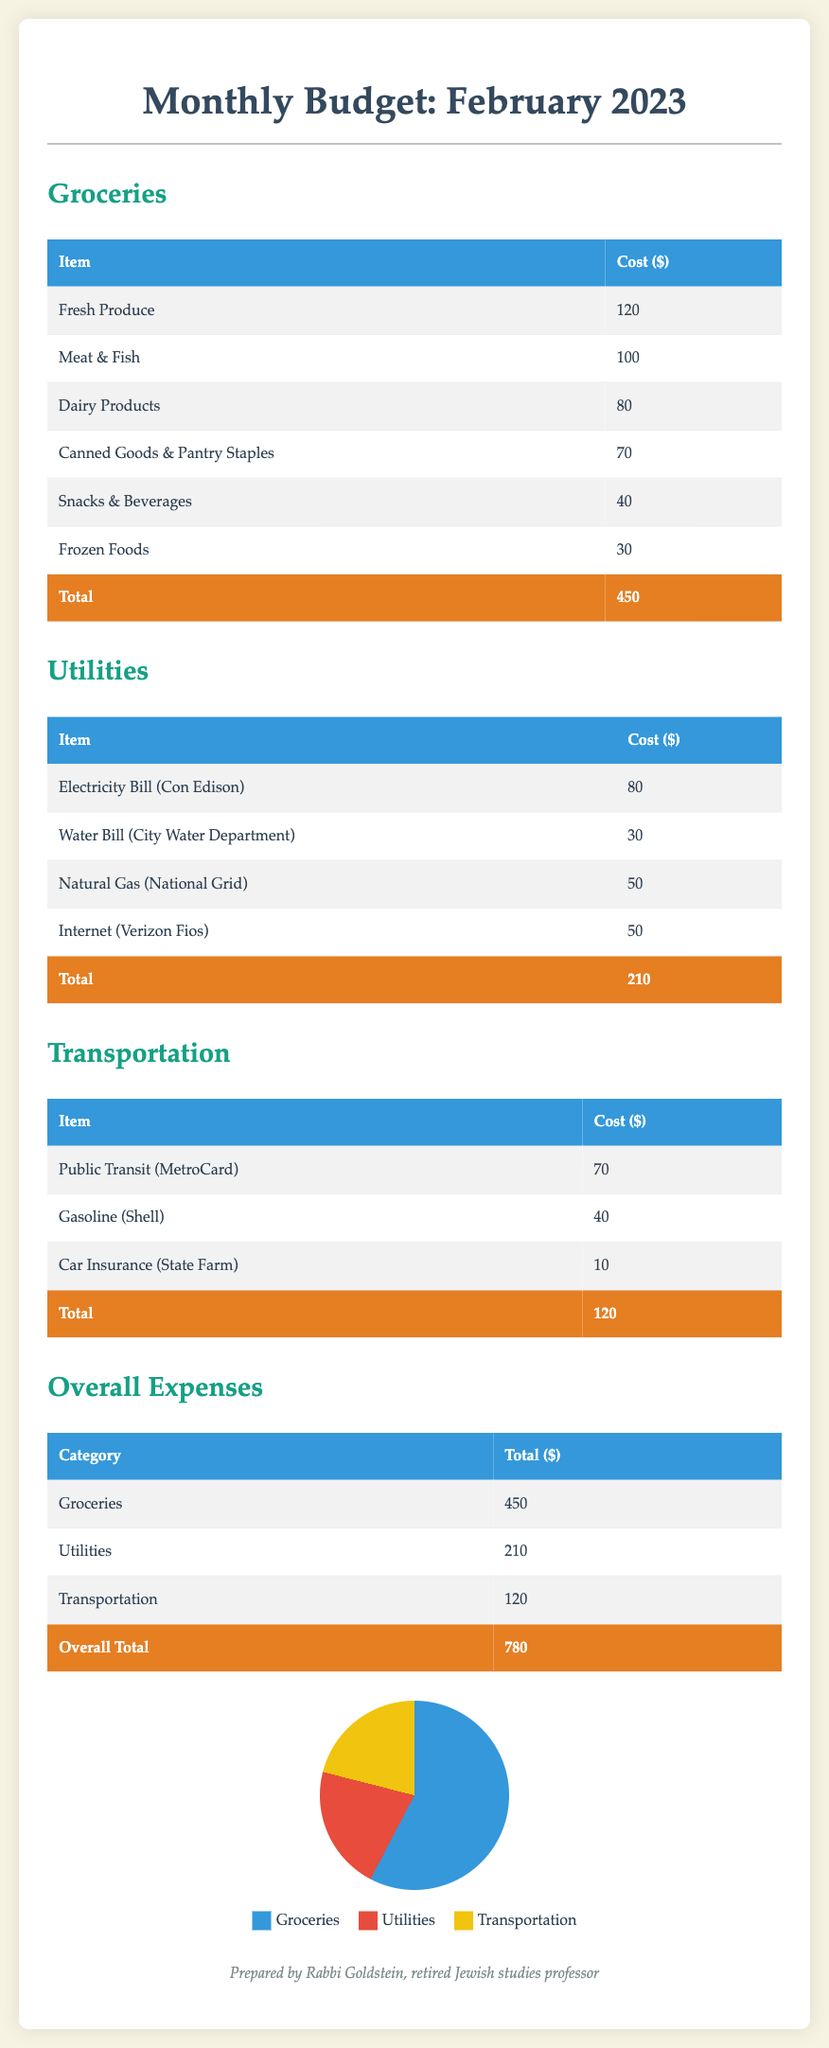What is the total cost for groceries? The total cost for groceries is calculated by adding all grocery items, which is $120 + $100 + $80 + $70 + $40 + $30 = $450.
Answer: $450 What is the cost of the electricity bill? The cost of the electricity bill listed under utilities is $80.
Answer: $80 What is the total expense for utilities? The total expense for utilities is the sum of all utility costs, which is $80 + $30 + $50 + $50 = $210.
Answer: $210 What are the transportation costs? Transportation costs include Public Transit, Gasoline, and Car Insurance totaling $70 + $40 + $10 = $120.
Answer: $120 Which category has the highest expense? Comparing the total expenses of groceries ($450), utilities ($210), and transportation ($120), groceries have the highest expense.
Answer: Groceries What is the total overall expense for February 2023? The overall total expense is the sum of all categories: $450 + $210 + $120 = $780.
Answer: $780 How much is spent on meat and fish? The amount spent specifically on meat and fish under groceries is $100.
Answer: $100 What is the cost for natural gas? The cost for natural gas, as listed under utilities, is $50.
Answer: $50 What percentage of the total budget is spent on utilities? To find the percentage spent on utilities, divide the utility total by overall total and multiply by 100: ($210 / $780) * 100 ≈ 26.92%.
Answer: 26.92% 